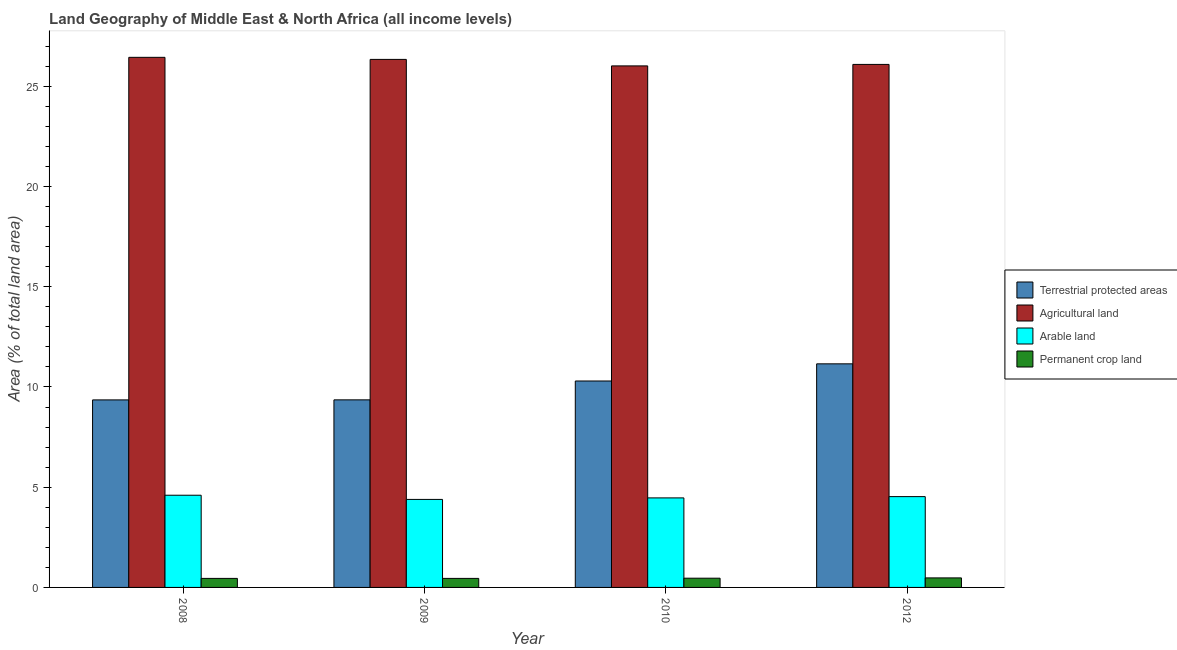How many groups of bars are there?
Keep it short and to the point. 4. Are the number of bars per tick equal to the number of legend labels?
Your answer should be compact. Yes. Are the number of bars on each tick of the X-axis equal?
Give a very brief answer. Yes. How many bars are there on the 3rd tick from the right?
Provide a succinct answer. 4. What is the label of the 2nd group of bars from the left?
Ensure brevity in your answer.  2009. In how many cases, is the number of bars for a given year not equal to the number of legend labels?
Provide a short and direct response. 0. What is the percentage of area under arable land in 2012?
Your answer should be compact. 4.53. Across all years, what is the maximum percentage of land under terrestrial protection?
Your answer should be compact. 11.15. Across all years, what is the minimum percentage of area under agricultural land?
Provide a short and direct response. 26.02. In which year was the percentage of area under agricultural land maximum?
Your answer should be compact. 2008. In which year was the percentage of land under terrestrial protection minimum?
Ensure brevity in your answer.  2008. What is the total percentage of area under arable land in the graph?
Offer a very short reply. 17.99. What is the difference between the percentage of area under arable land in 2009 and that in 2012?
Give a very brief answer. -0.14. What is the difference between the percentage of area under agricultural land in 2008 and the percentage of area under permanent crop land in 2012?
Provide a succinct answer. 0.35. What is the average percentage of area under arable land per year?
Offer a very short reply. 4.5. In the year 2012, what is the difference between the percentage of land under terrestrial protection and percentage of area under arable land?
Provide a short and direct response. 0. In how many years, is the percentage of area under agricultural land greater than 21 %?
Your answer should be compact. 4. What is the ratio of the percentage of area under agricultural land in 2009 to that in 2010?
Your answer should be compact. 1.01. Is the percentage of area under agricultural land in 2008 less than that in 2012?
Make the answer very short. No. Is the difference between the percentage of area under arable land in 2010 and 2012 greater than the difference between the percentage of area under permanent crop land in 2010 and 2012?
Give a very brief answer. No. What is the difference between the highest and the second highest percentage of area under agricultural land?
Keep it short and to the point. 0.1. What is the difference between the highest and the lowest percentage of land under terrestrial protection?
Your answer should be very brief. 1.8. Is the sum of the percentage of area under permanent crop land in 2008 and 2010 greater than the maximum percentage of land under terrestrial protection across all years?
Make the answer very short. Yes. What does the 3rd bar from the left in 2009 represents?
Offer a very short reply. Arable land. What does the 1st bar from the right in 2012 represents?
Give a very brief answer. Permanent crop land. Is it the case that in every year, the sum of the percentage of land under terrestrial protection and percentage of area under agricultural land is greater than the percentage of area under arable land?
Your response must be concise. Yes. Are all the bars in the graph horizontal?
Provide a short and direct response. No. How many years are there in the graph?
Make the answer very short. 4. What is the difference between two consecutive major ticks on the Y-axis?
Your response must be concise. 5. Where does the legend appear in the graph?
Provide a succinct answer. Center right. How many legend labels are there?
Provide a short and direct response. 4. What is the title of the graph?
Give a very brief answer. Land Geography of Middle East & North Africa (all income levels). Does "Others" appear as one of the legend labels in the graph?
Give a very brief answer. No. What is the label or title of the X-axis?
Your answer should be very brief. Year. What is the label or title of the Y-axis?
Keep it short and to the point. Area (% of total land area). What is the Area (% of total land area) of Terrestrial protected areas in 2008?
Give a very brief answer. 9.36. What is the Area (% of total land area) in Agricultural land in 2008?
Give a very brief answer. 26.44. What is the Area (% of total land area) in Arable land in 2008?
Keep it short and to the point. 4.6. What is the Area (% of total land area) in Permanent crop land in 2008?
Your answer should be very brief. 0.45. What is the Area (% of total land area) in Terrestrial protected areas in 2009?
Provide a short and direct response. 9.36. What is the Area (% of total land area) in Agricultural land in 2009?
Keep it short and to the point. 26.34. What is the Area (% of total land area) in Arable land in 2009?
Give a very brief answer. 4.39. What is the Area (% of total land area) in Permanent crop land in 2009?
Your answer should be very brief. 0.45. What is the Area (% of total land area) of Terrestrial protected areas in 2010?
Keep it short and to the point. 10.3. What is the Area (% of total land area) of Agricultural land in 2010?
Keep it short and to the point. 26.02. What is the Area (% of total land area) in Arable land in 2010?
Provide a succinct answer. 4.47. What is the Area (% of total land area) of Permanent crop land in 2010?
Give a very brief answer. 0.46. What is the Area (% of total land area) of Terrestrial protected areas in 2012?
Give a very brief answer. 11.15. What is the Area (% of total land area) of Agricultural land in 2012?
Provide a short and direct response. 26.09. What is the Area (% of total land area) in Arable land in 2012?
Your response must be concise. 4.53. What is the Area (% of total land area) in Permanent crop land in 2012?
Offer a terse response. 0.48. Across all years, what is the maximum Area (% of total land area) in Terrestrial protected areas?
Your answer should be compact. 11.15. Across all years, what is the maximum Area (% of total land area) in Agricultural land?
Provide a short and direct response. 26.44. Across all years, what is the maximum Area (% of total land area) of Arable land?
Keep it short and to the point. 4.6. Across all years, what is the maximum Area (% of total land area) of Permanent crop land?
Offer a very short reply. 0.48. Across all years, what is the minimum Area (% of total land area) in Terrestrial protected areas?
Provide a succinct answer. 9.36. Across all years, what is the minimum Area (% of total land area) in Agricultural land?
Your answer should be compact. 26.02. Across all years, what is the minimum Area (% of total land area) of Arable land?
Keep it short and to the point. 4.39. Across all years, what is the minimum Area (% of total land area) in Permanent crop land?
Your response must be concise. 0.45. What is the total Area (% of total land area) of Terrestrial protected areas in the graph?
Make the answer very short. 40.17. What is the total Area (% of total land area) of Agricultural land in the graph?
Make the answer very short. 104.9. What is the total Area (% of total land area) of Arable land in the graph?
Your answer should be compact. 17.99. What is the total Area (% of total land area) in Permanent crop land in the graph?
Your answer should be compact. 1.84. What is the difference between the Area (% of total land area) of Terrestrial protected areas in 2008 and that in 2009?
Offer a terse response. -0. What is the difference between the Area (% of total land area) in Agricultural land in 2008 and that in 2009?
Provide a succinct answer. 0.1. What is the difference between the Area (% of total land area) in Arable land in 2008 and that in 2009?
Ensure brevity in your answer.  0.21. What is the difference between the Area (% of total land area) in Permanent crop land in 2008 and that in 2009?
Provide a succinct answer. -0. What is the difference between the Area (% of total land area) of Terrestrial protected areas in 2008 and that in 2010?
Keep it short and to the point. -0.94. What is the difference between the Area (% of total land area) in Agricultural land in 2008 and that in 2010?
Provide a short and direct response. 0.43. What is the difference between the Area (% of total land area) in Arable land in 2008 and that in 2010?
Your answer should be very brief. 0.13. What is the difference between the Area (% of total land area) in Permanent crop land in 2008 and that in 2010?
Keep it short and to the point. -0.01. What is the difference between the Area (% of total land area) in Terrestrial protected areas in 2008 and that in 2012?
Offer a terse response. -1.8. What is the difference between the Area (% of total land area) of Agricultural land in 2008 and that in 2012?
Your answer should be very brief. 0.35. What is the difference between the Area (% of total land area) of Arable land in 2008 and that in 2012?
Ensure brevity in your answer.  0.07. What is the difference between the Area (% of total land area) of Permanent crop land in 2008 and that in 2012?
Your response must be concise. -0.03. What is the difference between the Area (% of total land area) in Terrestrial protected areas in 2009 and that in 2010?
Your response must be concise. -0.94. What is the difference between the Area (% of total land area) of Agricultural land in 2009 and that in 2010?
Keep it short and to the point. 0.32. What is the difference between the Area (% of total land area) of Arable land in 2009 and that in 2010?
Your answer should be very brief. -0.07. What is the difference between the Area (% of total land area) in Permanent crop land in 2009 and that in 2010?
Offer a very short reply. -0.01. What is the difference between the Area (% of total land area) in Terrestrial protected areas in 2009 and that in 2012?
Make the answer very short. -1.8. What is the difference between the Area (% of total land area) of Agricultural land in 2009 and that in 2012?
Make the answer very short. 0.25. What is the difference between the Area (% of total land area) in Arable land in 2009 and that in 2012?
Provide a succinct answer. -0.14. What is the difference between the Area (% of total land area) in Permanent crop land in 2009 and that in 2012?
Your response must be concise. -0.02. What is the difference between the Area (% of total land area) in Terrestrial protected areas in 2010 and that in 2012?
Keep it short and to the point. -0.86. What is the difference between the Area (% of total land area) in Agricultural land in 2010 and that in 2012?
Offer a terse response. -0.07. What is the difference between the Area (% of total land area) in Arable land in 2010 and that in 2012?
Your answer should be compact. -0.06. What is the difference between the Area (% of total land area) of Permanent crop land in 2010 and that in 2012?
Keep it short and to the point. -0.01. What is the difference between the Area (% of total land area) in Terrestrial protected areas in 2008 and the Area (% of total land area) in Agricultural land in 2009?
Provide a short and direct response. -16.99. What is the difference between the Area (% of total land area) in Terrestrial protected areas in 2008 and the Area (% of total land area) in Arable land in 2009?
Provide a succinct answer. 4.96. What is the difference between the Area (% of total land area) in Terrestrial protected areas in 2008 and the Area (% of total land area) in Permanent crop land in 2009?
Your response must be concise. 8.9. What is the difference between the Area (% of total land area) of Agricultural land in 2008 and the Area (% of total land area) of Arable land in 2009?
Keep it short and to the point. 22.05. What is the difference between the Area (% of total land area) of Agricultural land in 2008 and the Area (% of total land area) of Permanent crop land in 2009?
Ensure brevity in your answer.  25.99. What is the difference between the Area (% of total land area) in Arable land in 2008 and the Area (% of total land area) in Permanent crop land in 2009?
Your answer should be very brief. 4.15. What is the difference between the Area (% of total land area) in Terrestrial protected areas in 2008 and the Area (% of total land area) in Agricultural land in 2010?
Make the answer very short. -16.66. What is the difference between the Area (% of total land area) of Terrestrial protected areas in 2008 and the Area (% of total land area) of Arable land in 2010?
Provide a succinct answer. 4.89. What is the difference between the Area (% of total land area) in Terrestrial protected areas in 2008 and the Area (% of total land area) in Permanent crop land in 2010?
Give a very brief answer. 8.89. What is the difference between the Area (% of total land area) of Agricultural land in 2008 and the Area (% of total land area) of Arable land in 2010?
Provide a short and direct response. 21.98. What is the difference between the Area (% of total land area) in Agricultural land in 2008 and the Area (% of total land area) in Permanent crop land in 2010?
Offer a terse response. 25.98. What is the difference between the Area (% of total land area) in Arable land in 2008 and the Area (% of total land area) in Permanent crop land in 2010?
Your response must be concise. 4.14. What is the difference between the Area (% of total land area) of Terrestrial protected areas in 2008 and the Area (% of total land area) of Agricultural land in 2012?
Give a very brief answer. -16.74. What is the difference between the Area (% of total land area) of Terrestrial protected areas in 2008 and the Area (% of total land area) of Arable land in 2012?
Your answer should be very brief. 4.82. What is the difference between the Area (% of total land area) in Terrestrial protected areas in 2008 and the Area (% of total land area) in Permanent crop land in 2012?
Make the answer very short. 8.88. What is the difference between the Area (% of total land area) in Agricultural land in 2008 and the Area (% of total land area) in Arable land in 2012?
Keep it short and to the point. 21.91. What is the difference between the Area (% of total land area) of Agricultural land in 2008 and the Area (% of total land area) of Permanent crop land in 2012?
Make the answer very short. 25.97. What is the difference between the Area (% of total land area) in Arable land in 2008 and the Area (% of total land area) in Permanent crop land in 2012?
Provide a succinct answer. 4.12. What is the difference between the Area (% of total land area) of Terrestrial protected areas in 2009 and the Area (% of total land area) of Agricultural land in 2010?
Provide a succinct answer. -16.66. What is the difference between the Area (% of total land area) in Terrestrial protected areas in 2009 and the Area (% of total land area) in Arable land in 2010?
Offer a very short reply. 4.89. What is the difference between the Area (% of total land area) in Terrestrial protected areas in 2009 and the Area (% of total land area) in Permanent crop land in 2010?
Ensure brevity in your answer.  8.9. What is the difference between the Area (% of total land area) of Agricultural land in 2009 and the Area (% of total land area) of Arable land in 2010?
Give a very brief answer. 21.88. What is the difference between the Area (% of total land area) of Agricultural land in 2009 and the Area (% of total land area) of Permanent crop land in 2010?
Offer a very short reply. 25.88. What is the difference between the Area (% of total land area) of Arable land in 2009 and the Area (% of total land area) of Permanent crop land in 2010?
Your answer should be compact. 3.93. What is the difference between the Area (% of total land area) in Terrestrial protected areas in 2009 and the Area (% of total land area) in Agricultural land in 2012?
Offer a very short reply. -16.73. What is the difference between the Area (% of total land area) of Terrestrial protected areas in 2009 and the Area (% of total land area) of Arable land in 2012?
Offer a terse response. 4.83. What is the difference between the Area (% of total land area) in Terrestrial protected areas in 2009 and the Area (% of total land area) in Permanent crop land in 2012?
Your answer should be very brief. 8.88. What is the difference between the Area (% of total land area) in Agricultural land in 2009 and the Area (% of total land area) in Arable land in 2012?
Give a very brief answer. 21.81. What is the difference between the Area (% of total land area) in Agricultural land in 2009 and the Area (% of total land area) in Permanent crop land in 2012?
Your answer should be very brief. 25.87. What is the difference between the Area (% of total land area) in Arable land in 2009 and the Area (% of total land area) in Permanent crop land in 2012?
Offer a very short reply. 3.92. What is the difference between the Area (% of total land area) in Terrestrial protected areas in 2010 and the Area (% of total land area) in Agricultural land in 2012?
Your answer should be compact. -15.79. What is the difference between the Area (% of total land area) of Terrestrial protected areas in 2010 and the Area (% of total land area) of Arable land in 2012?
Your response must be concise. 5.77. What is the difference between the Area (% of total land area) in Terrestrial protected areas in 2010 and the Area (% of total land area) in Permanent crop land in 2012?
Keep it short and to the point. 9.82. What is the difference between the Area (% of total land area) of Agricultural land in 2010 and the Area (% of total land area) of Arable land in 2012?
Offer a very short reply. 21.49. What is the difference between the Area (% of total land area) of Agricultural land in 2010 and the Area (% of total land area) of Permanent crop land in 2012?
Your answer should be compact. 25.54. What is the difference between the Area (% of total land area) in Arable land in 2010 and the Area (% of total land area) in Permanent crop land in 2012?
Offer a terse response. 3.99. What is the average Area (% of total land area) in Terrestrial protected areas per year?
Give a very brief answer. 10.04. What is the average Area (% of total land area) of Agricultural land per year?
Provide a short and direct response. 26.22. What is the average Area (% of total land area) in Arable land per year?
Your answer should be very brief. 4.5. What is the average Area (% of total land area) in Permanent crop land per year?
Your answer should be very brief. 0.46. In the year 2008, what is the difference between the Area (% of total land area) in Terrestrial protected areas and Area (% of total land area) in Agricultural land?
Give a very brief answer. -17.09. In the year 2008, what is the difference between the Area (% of total land area) of Terrestrial protected areas and Area (% of total land area) of Arable land?
Your answer should be very brief. 4.76. In the year 2008, what is the difference between the Area (% of total land area) in Terrestrial protected areas and Area (% of total land area) in Permanent crop land?
Keep it short and to the point. 8.91. In the year 2008, what is the difference between the Area (% of total land area) in Agricultural land and Area (% of total land area) in Arable land?
Keep it short and to the point. 21.85. In the year 2008, what is the difference between the Area (% of total land area) of Agricultural land and Area (% of total land area) of Permanent crop land?
Give a very brief answer. 25.99. In the year 2008, what is the difference between the Area (% of total land area) of Arable land and Area (% of total land area) of Permanent crop land?
Offer a terse response. 4.15. In the year 2009, what is the difference between the Area (% of total land area) of Terrestrial protected areas and Area (% of total land area) of Agricultural land?
Provide a succinct answer. -16.98. In the year 2009, what is the difference between the Area (% of total land area) in Terrestrial protected areas and Area (% of total land area) in Arable land?
Your answer should be very brief. 4.97. In the year 2009, what is the difference between the Area (% of total land area) of Terrestrial protected areas and Area (% of total land area) of Permanent crop land?
Offer a very short reply. 8.91. In the year 2009, what is the difference between the Area (% of total land area) in Agricultural land and Area (% of total land area) in Arable land?
Ensure brevity in your answer.  21.95. In the year 2009, what is the difference between the Area (% of total land area) in Agricultural land and Area (% of total land area) in Permanent crop land?
Provide a succinct answer. 25.89. In the year 2009, what is the difference between the Area (% of total land area) of Arable land and Area (% of total land area) of Permanent crop land?
Keep it short and to the point. 3.94. In the year 2010, what is the difference between the Area (% of total land area) in Terrestrial protected areas and Area (% of total land area) in Agricultural land?
Provide a succinct answer. -15.72. In the year 2010, what is the difference between the Area (% of total land area) of Terrestrial protected areas and Area (% of total land area) of Arable land?
Offer a very short reply. 5.83. In the year 2010, what is the difference between the Area (% of total land area) in Terrestrial protected areas and Area (% of total land area) in Permanent crop land?
Your response must be concise. 9.84. In the year 2010, what is the difference between the Area (% of total land area) in Agricultural land and Area (% of total land area) in Arable land?
Make the answer very short. 21.55. In the year 2010, what is the difference between the Area (% of total land area) of Agricultural land and Area (% of total land area) of Permanent crop land?
Offer a terse response. 25.56. In the year 2010, what is the difference between the Area (% of total land area) of Arable land and Area (% of total land area) of Permanent crop land?
Your answer should be very brief. 4.01. In the year 2012, what is the difference between the Area (% of total land area) in Terrestrial protected areas and Area (% of total land area) in Agricultural land?
Your answer should be compact. -14.94. In the year 2012, what is the difference between the Area (% of total land area) in Terrestrial protected areas and Area (% of total land area) in Arable land?
Your answer should be compact. 6.62. In the year 2012, what is the difference between the Area (% of total land area) of Terrestrial protected areas and Area (% of total land area) of Permanent crop land?
Make the answer very short. 10.68. In the year 2012, what is the difference between the Area (% of total land area) of Agricultural land and Area (% of total land area) of Arable land?
Give a very brief answer. 21.56. In the year 2012, what is the difference between the Area (% of total land area) in Agricultural land and Area (% of total land area) in Permanent crop land?
Provide a succinct answer. 25.62. In the year 2012, what is the difference between the Area (% of total land area) of Arable land and Area (% of total land area) of Permanent crop land?
Your response must be concise. 4.06. What is the ratio of the Area (% of total land area) in Terrestrial protected areas in 2008 to that in 2009?
Your answer should be compact. 1. What is the ratio of the Area (% of total land area) of Agricultural land in 2008 to that in 2009?
Give a very brief answer. 1. What is the ratio of the Area (% of total land area) of Arable land in 2008 to that in 2009?
Provide a succinct answer. 1.05. What is the ratio of the Area (% of total land area) in Terrestrial protected areas in 2008 to that in 2010?
Keep it short and to the point. 0.91. What is the ratio of the Area (% of total land area) in Agricultural land in 2008 to that in 2010?
Offer a very short reply. 1.02. What is the ratio of the Area (% of total land area) of Arable land in 2008 to that in 2010?
Your answer should be very brief. 1.03. What is the ratio of the Area (% of total land area) of Permanent crop land in 2008 to that in 2010?
Give a very brief answer. 0.98. What is the ratio of the Area (% of total land area) of Terrestrial protected areas in 2008 to that in 2012?
Your response must be concise. 0.84. What is the ratio of the Area (% of total land area) in Agricultural land in 2008 to that in 2012?
Your answer should be compact. 1.01. What is the ratio of the Area (% of total land area) of Arable land in 2008 to that in 2012?
Your response must be concise. 1.02. What is the ratio of the Area (% of total land area) in Permanent crop land in 2008 to that in 2012?
Offer a terse response. 0.95. What is the ratio of the Area (% of total land area) in Terrestrial protected areas in 2009 to that in 2010?
Your response must be concise. 0.91. What is the ratio of the Area (% of total land area) in Agricultural land in 2009 to that in 2010?
Provide a succinct answer. 1.01. What is the ratio of the Area (% of total land area) in Arable land in 2009 to that in 2010?
Offer a very short reply. 0.98. What is the ratio of the Area (% of total land area) in Permanent crop land in 2009 to that in 2010?
Provide a short and direct response. 0.98. What is the ratio of the Area (% of total land area) in Terrestrial protected areas in 2009 to that in 2012?
Offer a very short reply. 0.84. What is the ratio of the Area (% of total land area) of Agricultural land in 2009 to that in 2012?
Provide a succinct answer. 1.01. What is the ratio of the Area (% of total land area) in Arable land in 2009 to that in 2012?
Provide a short and direct response. 0.97. What is the ratio of the Area (% of total land area) of Permanent crop land in 2009 to that in 2012?
Give a very brief answer. 0.95. What is the ratio of the Area (% of total land area) in Terrestrial protected areas in 2010 to that in 2012?
Provide a short and direct response. 0.92. What is the ratio of the Area (% of total land area) of Agricultural land in 2010 to that in 2012?
Your answer should be compact. 1. What is the ratio of the Area (% of total land area) of Arable land in 2010 to that in 2012?
Provide a succinct answer. 0.99. What is the ratio of the Area (% of total land area) in Permanent crop land in 2010 to that in 2012?
Give a very brief answer. 0.97. What is the difference between the highest and the second highest Area (% of total land area) of Terrestrial protected areas?
Provide a short and direct response. 0.86. What is the difference between the highest and the second highest Area (% of total land area) in Agricultural land?
Your answer should be compact. 0.1. What is the difference between the highest and the second highest Area (% of total land area) of Arable land?
Your answer should be compact. 0.07. What is the difference between the highest and the second highest Area (% of total land area) of Permanent crop land?
Offer a terse response. 0.01. What is the difference between the highest and the lowest Area (% of total land area) in Terrestrial protected areas?
Make the answer very short. 1.8. What is the difference between the highest and the lowest Area (% of total land area) in Agricultural land?
Make the answer very short. 0.43. What is the difference between the highest and the lowest Area (% of total land area) in Arable land?
Your answer should be very brief. 0.21. What is the difference between the highest and the lowest Area (% of total land area) of Permanent crop land?
Your answer should be compact. 0.03. 